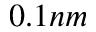<formula> <loc_0><loc_0><loc_500><loc_500>0 . 1 n m</formula> 